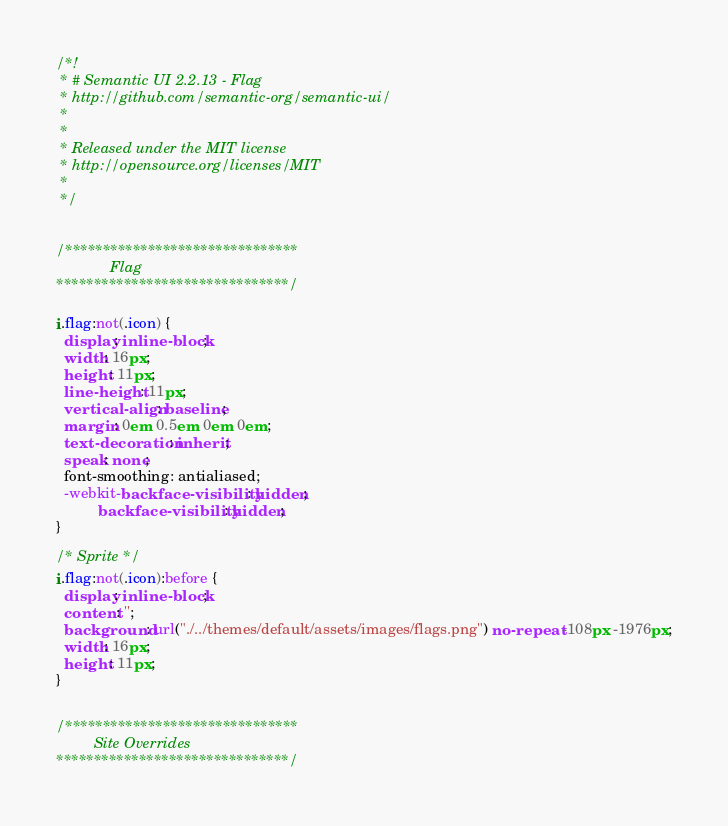Convert code to text. <code><loc_0><loc_0><loc_500><loc_500><_CSS_>/*!
 * # Semantic UI 2.2.13 - Flag
 * http://github.com/semantic-org/semantic-ui/
 *
 *
 * Released under the MIT license
 * http://opensource.org/licenses/MIT
 *
 */


/*******************************
             Flag
*******************************/

i.flag:not(.icon) {
  display: inline-block;
  width: 16px;
  height: 11px;
  line-height: 11px;
  vertical-align: baseline;
  margin: 0em 0.5em 0em 0em;
  text-decoration: inherit;
  speak: none;
  font-smoothing: antialiased;
  -webkit-backface-visibility: hidden;
          backface-visibility: hidden;
}

/* Sprite */
i.flag:not(.icon):before {
  display: inline-block;
  content: '';
  background: url("./../themes/default/assets/images/flags.png") no-repeat -108px -1976px;
  width: 16px;
  height: 11px;
}


/*******************************
         Site Overrides
*******************************/

</code> 